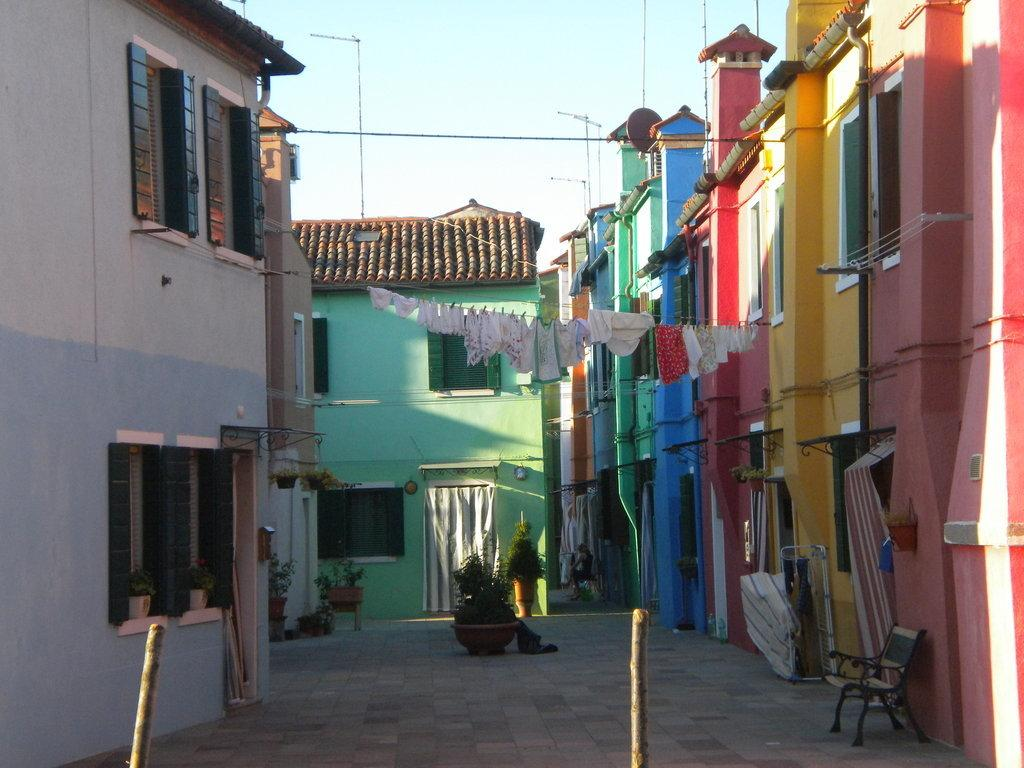What type of structures can be seen in the image? There are multi-colored buildings in the image. What colors are the clothes in the image? The clothes in the image are in white and red colors. What color are the plants in the image? The plants in the image are in green color. What type of seating is present in the image? There is a bench in the image. What objects can be seen in the background of the image? There are poles visible in the background of the image. What is the color of the sky in the image? The sky is white in color. How many family members can be seen waving at the house in the image? There are no family members or houses present in the image. What type of wave is depicted in the image? There is no wave depicted in the image. 